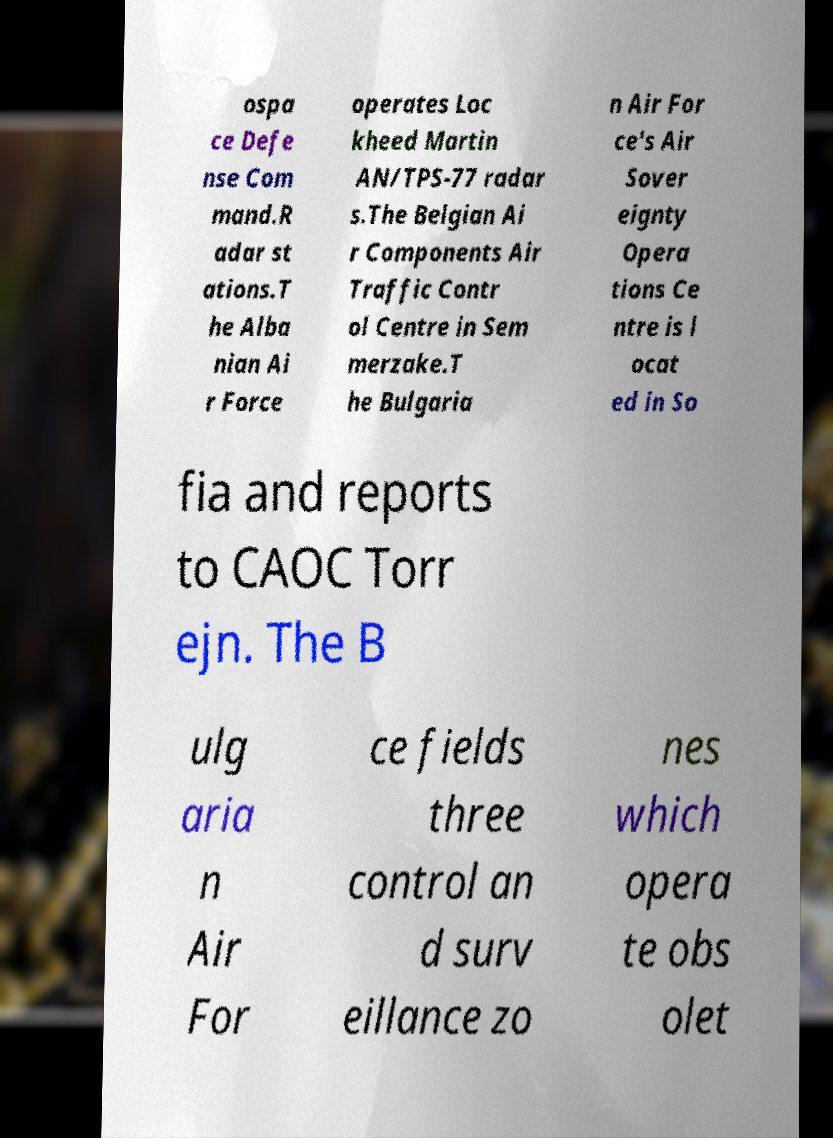Please identify and transcribe the text found in this image. ospa ce Defe nse Com mand.R adar st ations.T he Alba nian Ai r Force operates Loc kheed Martin AN/TPS-77 radar s.The Belgian Ai r Components Air Traffic Contr ol Centre in Sem merzake.T he Bulgaria n Air For ce's Air Sover eignty Opera tions Ce ntre is l ocat ed in So fia and reports to CAOC Torr ejn. The B ulg aria n Air For ce fields three control an d surv eillance zo nes which opera te obs olet 